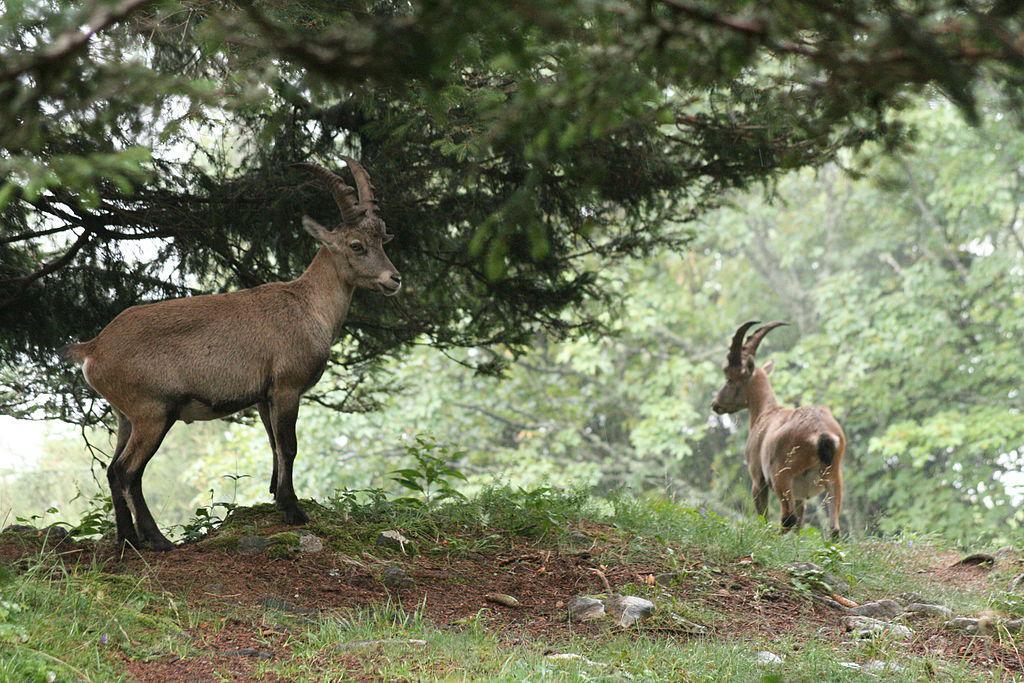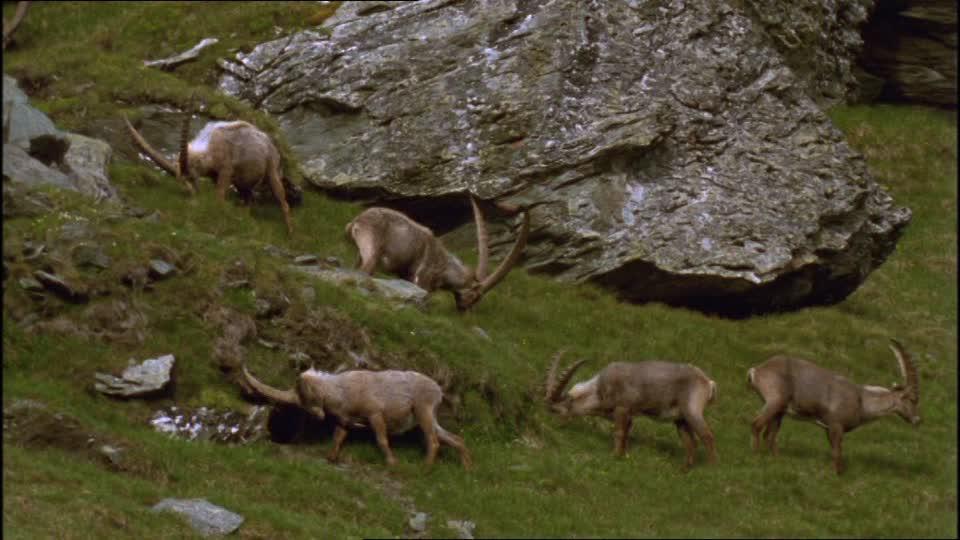The first image is the image on the left, the second image is the image on the right. For the images shown, is this caption "The right image includes at least twice the number of horned animals as the left image." true? Answer yes or no. Yes. The first image is the image on the left, the second image is the image on the right. Examine the images to the left and right. Is the description "The left image shows two animals standing under a tree." accurate? Answer yes or no. Yes. 